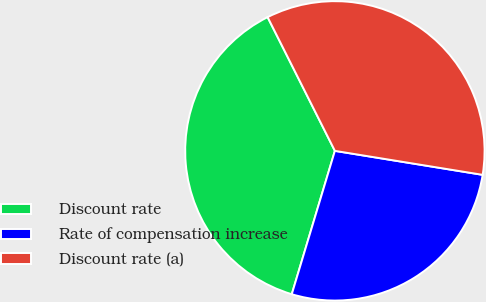Convert chart to OTSL. <chart><loc_0><loc_0><loc_500><loc_500><pie_chart><fcel>Discount rate<fcel>Rate of compensation increase<fcel>Discount rate (a)<nl><fcel>37.93%<fcel>27.09%<fcel>34.98%<nl></chart> 